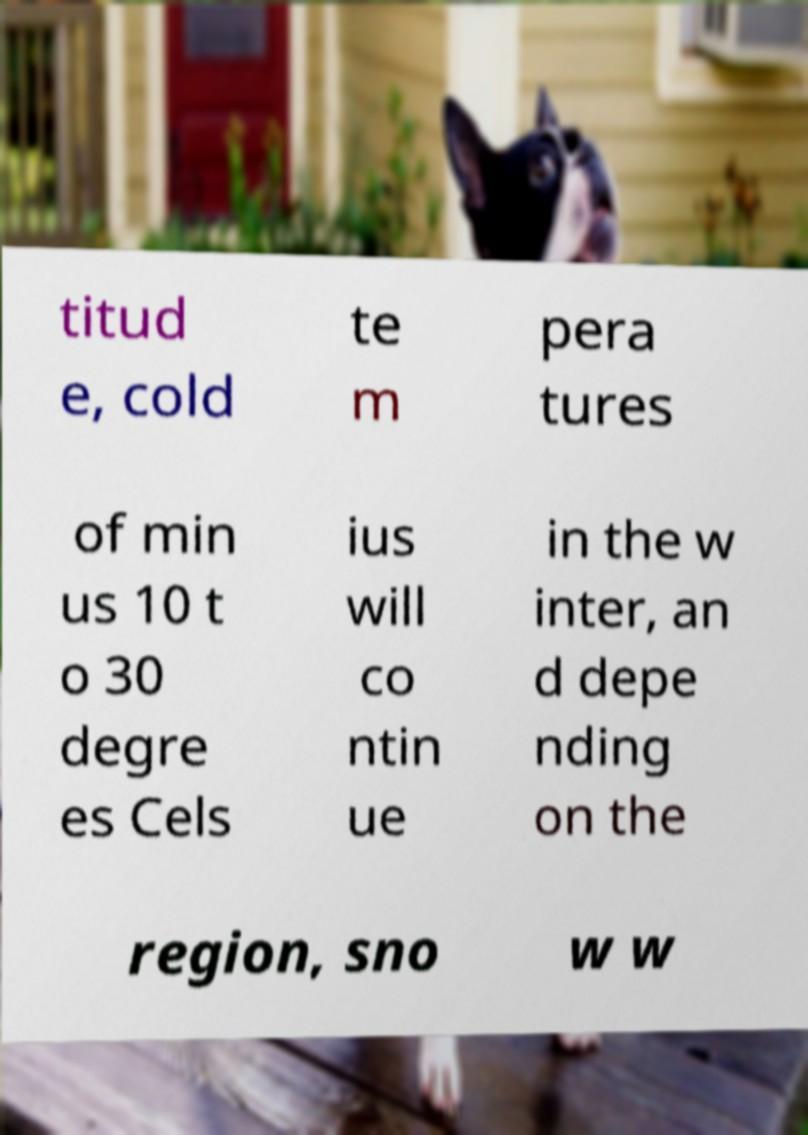I need the written content from this picture converted into text. Can you do that? titud e, cold te m pera tures of min us 10 t o 30 degre es Cels ius will co ntin ue in the w inter, an d depe nding on the region, sno w w 